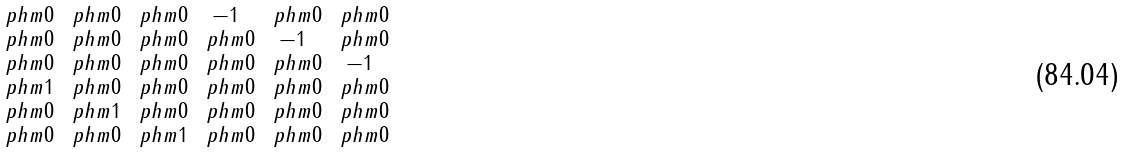<formula> <loc_0><loc_0><loc_500><loc_500>\begin{smallmatrix} \ p h m 0 & \ p h m 0 & \ p h m 0 & - 1 & \ p h m 0 & \ p h m 0 \\ \ p h m 0 & \ p h m 0 & \ p h m 0 & \ p h m 0 & - 1 & \ p h m 0 \\ \ p h m 0 & \ p h m 0 & \ p h m 0 & \ p h m 0 & \ p h m 0 & - 1 \\ \ p h m 1 & \ p h m 0 & \ p h m 0 & \ p h m 0 & \ p h m 0 & \ p h m 0 \\ \ p h m 0 & \ p h m 1 & \ p h m 0 & \ p h m 0 & \ p h m 0 & \ p h m 0 \\ \ p h m 0 & \ p h m 0 & \ p h m 1 & \ p h m 0 & \ p h m 0 & \ p h m 0 \\ \end{smallmatrix}</formula> 